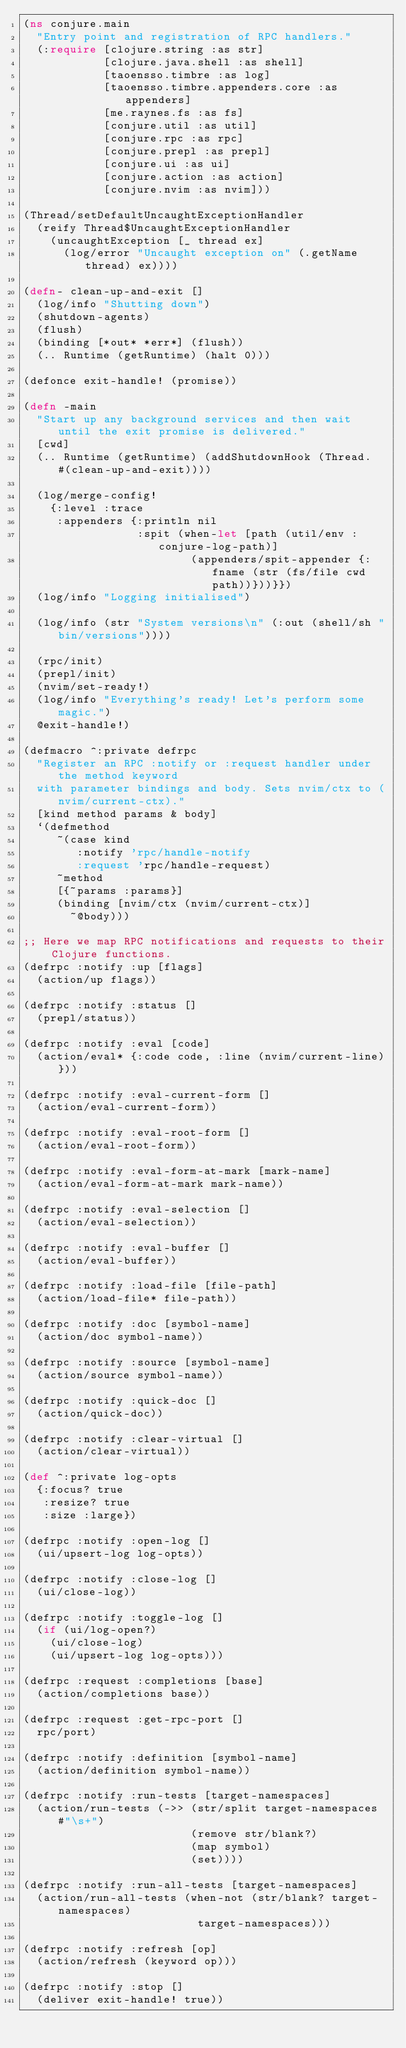Convert code to text. <code><loc_0><loc_0><loc_500><loc_500><_Clojure_>(ns conjure.main
  "Entry point and registration of RPC handlers."
  (:require [clojure.string :as str]
            [clojure.java.shell :as shell]
            [taoensso.timbre :as log]
            [taoensso.timbre.appenders.core :as appenders]
            [me.raynes.fs :as fs]
            [conjure.util :as util]
            [conjure.rpc :as rpc]
            [conjure.prepl :as prepl]
            [conjure.ui :as ui]
            [conjure.action :as action]
            [conjure.nvim :as nvim]))

(Thread/setDefaultUncaughtExceptionHandler
  (reify Thread$UncaughtExceptionHandler
    (uncaughtException [_ thread ex]
      (log/error "Uncaught exception on" (.getName thread) ex))))

(defn- clean-up-and-exit []
  (log/info "Shutting down")
  (shutdown-agents)
  (flush)
  (binding [*out* *err*] (flush))
  (.. Runtime (getRuntime) (halt 0)))

(defonce exit-handle! (promise))

(defn -main
  "Start up any background services and then wait until the exit promise is delivered."
  [cwd]
  (.. Runtime (getRuntime) (addShutdownHook (Thread. #(clean-up-and-exit))))

  (log/merge-config!
    {:level :trace
     :appenders {:println nil
                 :spit (when-let [path (util/env :conjure-log-path)]
                         (appenders/spit-appender {:fname (str (fs/file cwd path))}))}})
  (log/info "Logging initialised")

  (log/info (str "System versions\n" (:out (shell/sh "bin/versions"))))

  (rpc/init)
  (prepl/init)
  (nvim/set-ready!)
  (log/info "Everything's ready! Let's perform some magic.")
  @exit-handle!)

(defmacro ^:private defrpc
  "Register an RPC :notify or :request handler under the method keyword
  with parameter bindings and body. Sets nvim/ctx to (nvim/current-ctx)."
  [kind method params & body]
  `(defmethod
     ~(case kind
        :notify 'rpc/handle-notify
        :request 'rpc/handle-request)
     ~method
     [{~params :params}]
     (binding [nvim/ctx (nvim/current-ctx)]
       ~@body)))

;; Here we map RPC notifications and requests to their Clojure functions.
(defrpc :notify :up [flags]
  (action/up flags))

(defrpc :notify :status []
  (prepl/status))

(defrpc :notify :eval [code]
  (action/eval* {:code code, :line (nvim/current-line)}))

(defrpc :notify :eval-current-form []
  (action/eval-current-form))

(defrpc :notify :eval-root-form []
  (action/eval-root-form))

(defrpc :notify :eval-form-at-mark [mark-name]
  (action/eval-form-at-mark mark-name))

(defrpc :notify :eval-selection []
  (action/eval-selection))

(defrpc :notify :eval-buffer []
  (action/eval-buffer))

(defrpc :notify :load-file [file-path]
  (action/load-file* file-path))

(defrpc :notify :doc [symbol-name]
  (action/doc symbol-name))

(defrpc :notify :source [symbol-name]
  (action/source symbol-name))

(defrpc :notify :quick-doc []
  (action/quick-doc))

(defrpc :notify :clear-virtual []
  (action/clear-virtual))

(def ^:private log-opts
  {:focus? true
   :resize? true
   :size :large})

(defrpc :notify :open-log []
  (ui/upsert-log log-opts))

(defrpc :notify :close-log []
  (ui/close-log))

(defrpc :notify :toggle-log []
  (if (ui/log-open?)
    (ui/close-log)
    (ui/upsert-log log-opts)))

(defrpc :request :completions [base]
  (action/completions base))

(defrpc :request :get-rpc-port []
  rpc/port)

(defrpc :notify :definition [symbol-name]
  (action/definition symbol-name))

(defrpc :notify :run-tests [target-namespaces]
  (action/run-tests (->> (str/split target-namespaces #"\s+")
                         (remove str/blank?)
                         (map symbol)
                         (set))))

(defrpc :notify :run-all-tests [target-namespaces]
  (action/run-all-tests (when-not (str/blank? target-namespaces)
                          target-namespaces)))

(defrpc :notify :refresh [op]
  (action/refresh (keyword op)))

(defrpc :notify :stop []
  (deliver exit-handle! true))
</code> 